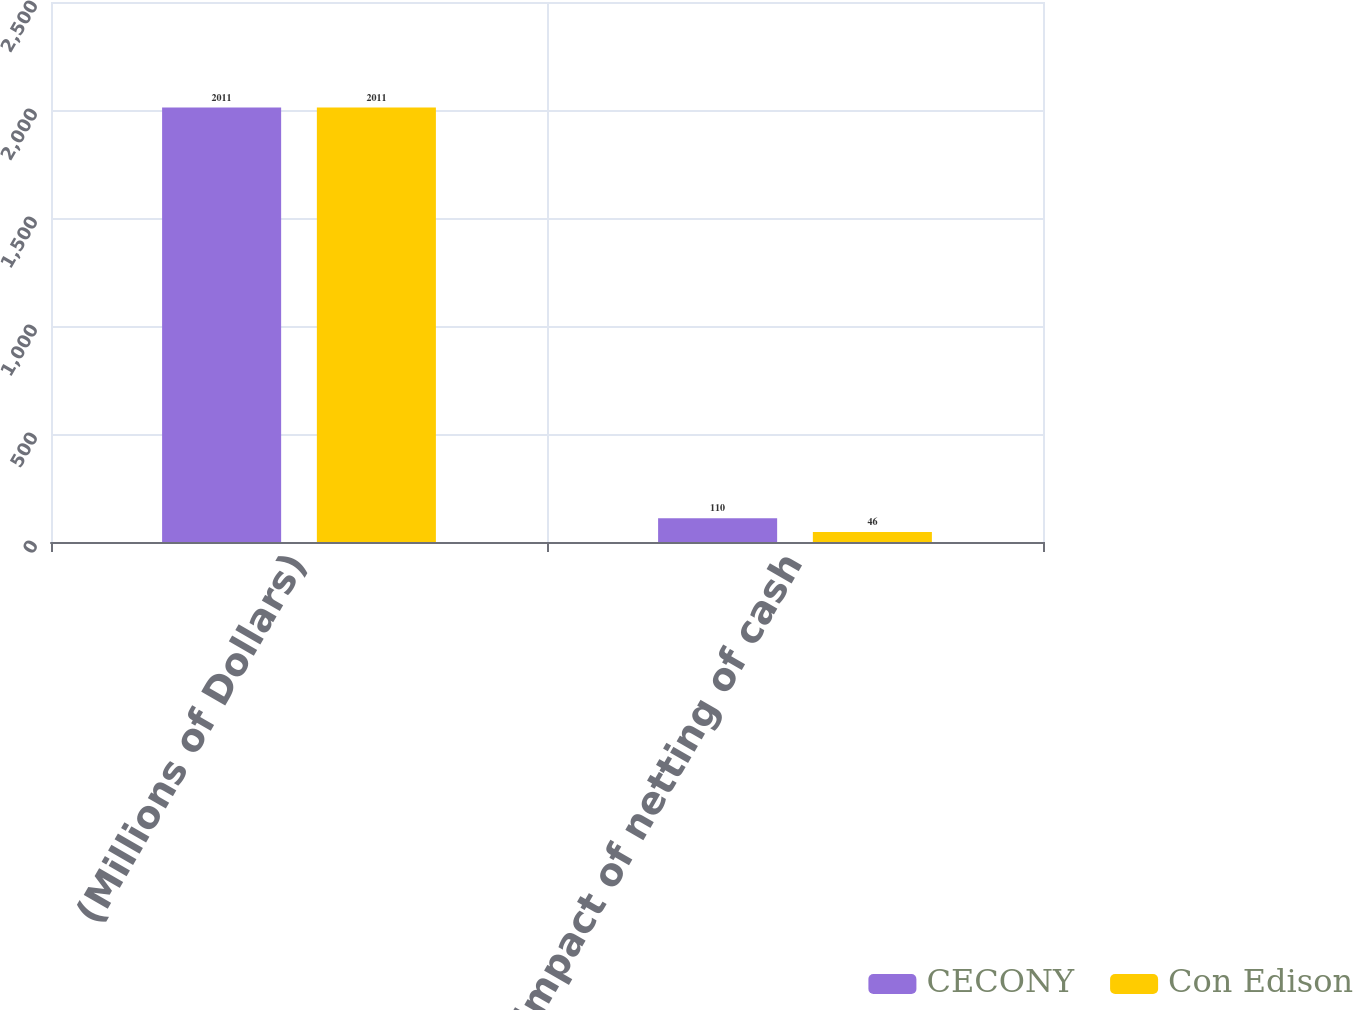Convert chart to OTSL. <chart><loc_0><loc_0><loc_500><loc_500><stacked_bar_chart><ecel><fcel>(Millions of Dollars)<fcel>Impact of netting of cash<nl><fcel>CECONY<fcel>2011<fcel>110<nl><fcel>Con Edison<fcel>2011<fcel>46<nl></chart> 